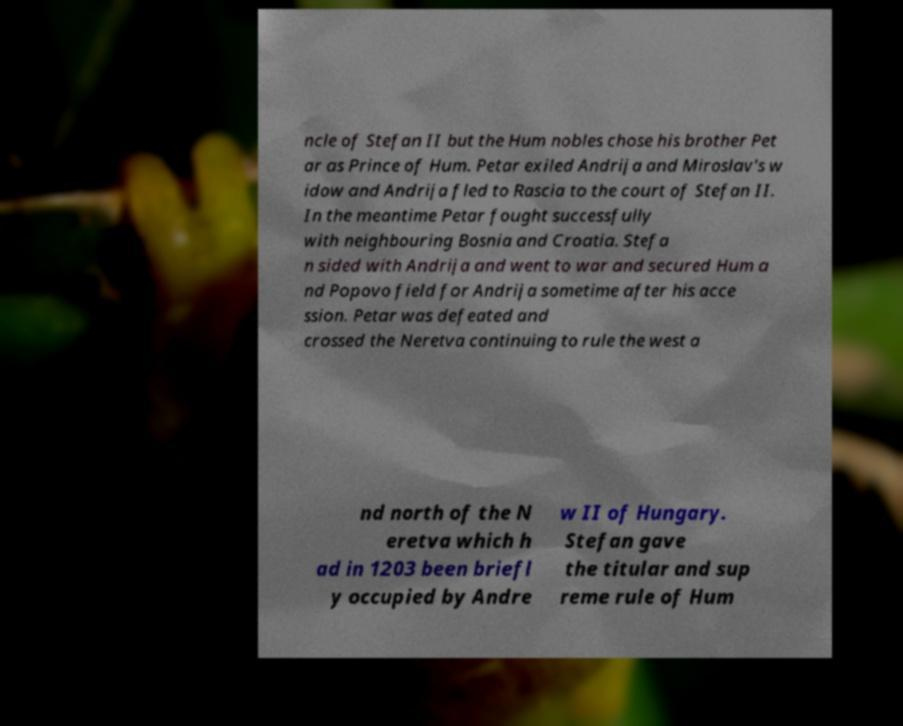Could you extract and type out the text from this image? ncle of Stefan II but the Hum nobles chose his brother Pet ar as Prince of Hum. Petar exiled Andrija and Miroslav's w idow and Andrija fled to Rascia to the court of Stefan II. In the meantime Petar fought successfully with neighbouring Bosnia and Croatia. Stefa n sided with Andrija and went to war and secured Hum a nd Popovo field for Andrija sometime after his acce ssion. Petar was defeated and crossed the Neretva continuing to rule the west a nd north of the N eretva which h ad in 1203 been briefl y occupied by Andre w II of Hungary. Stefan gave the titular and sup reme rule of Hum 